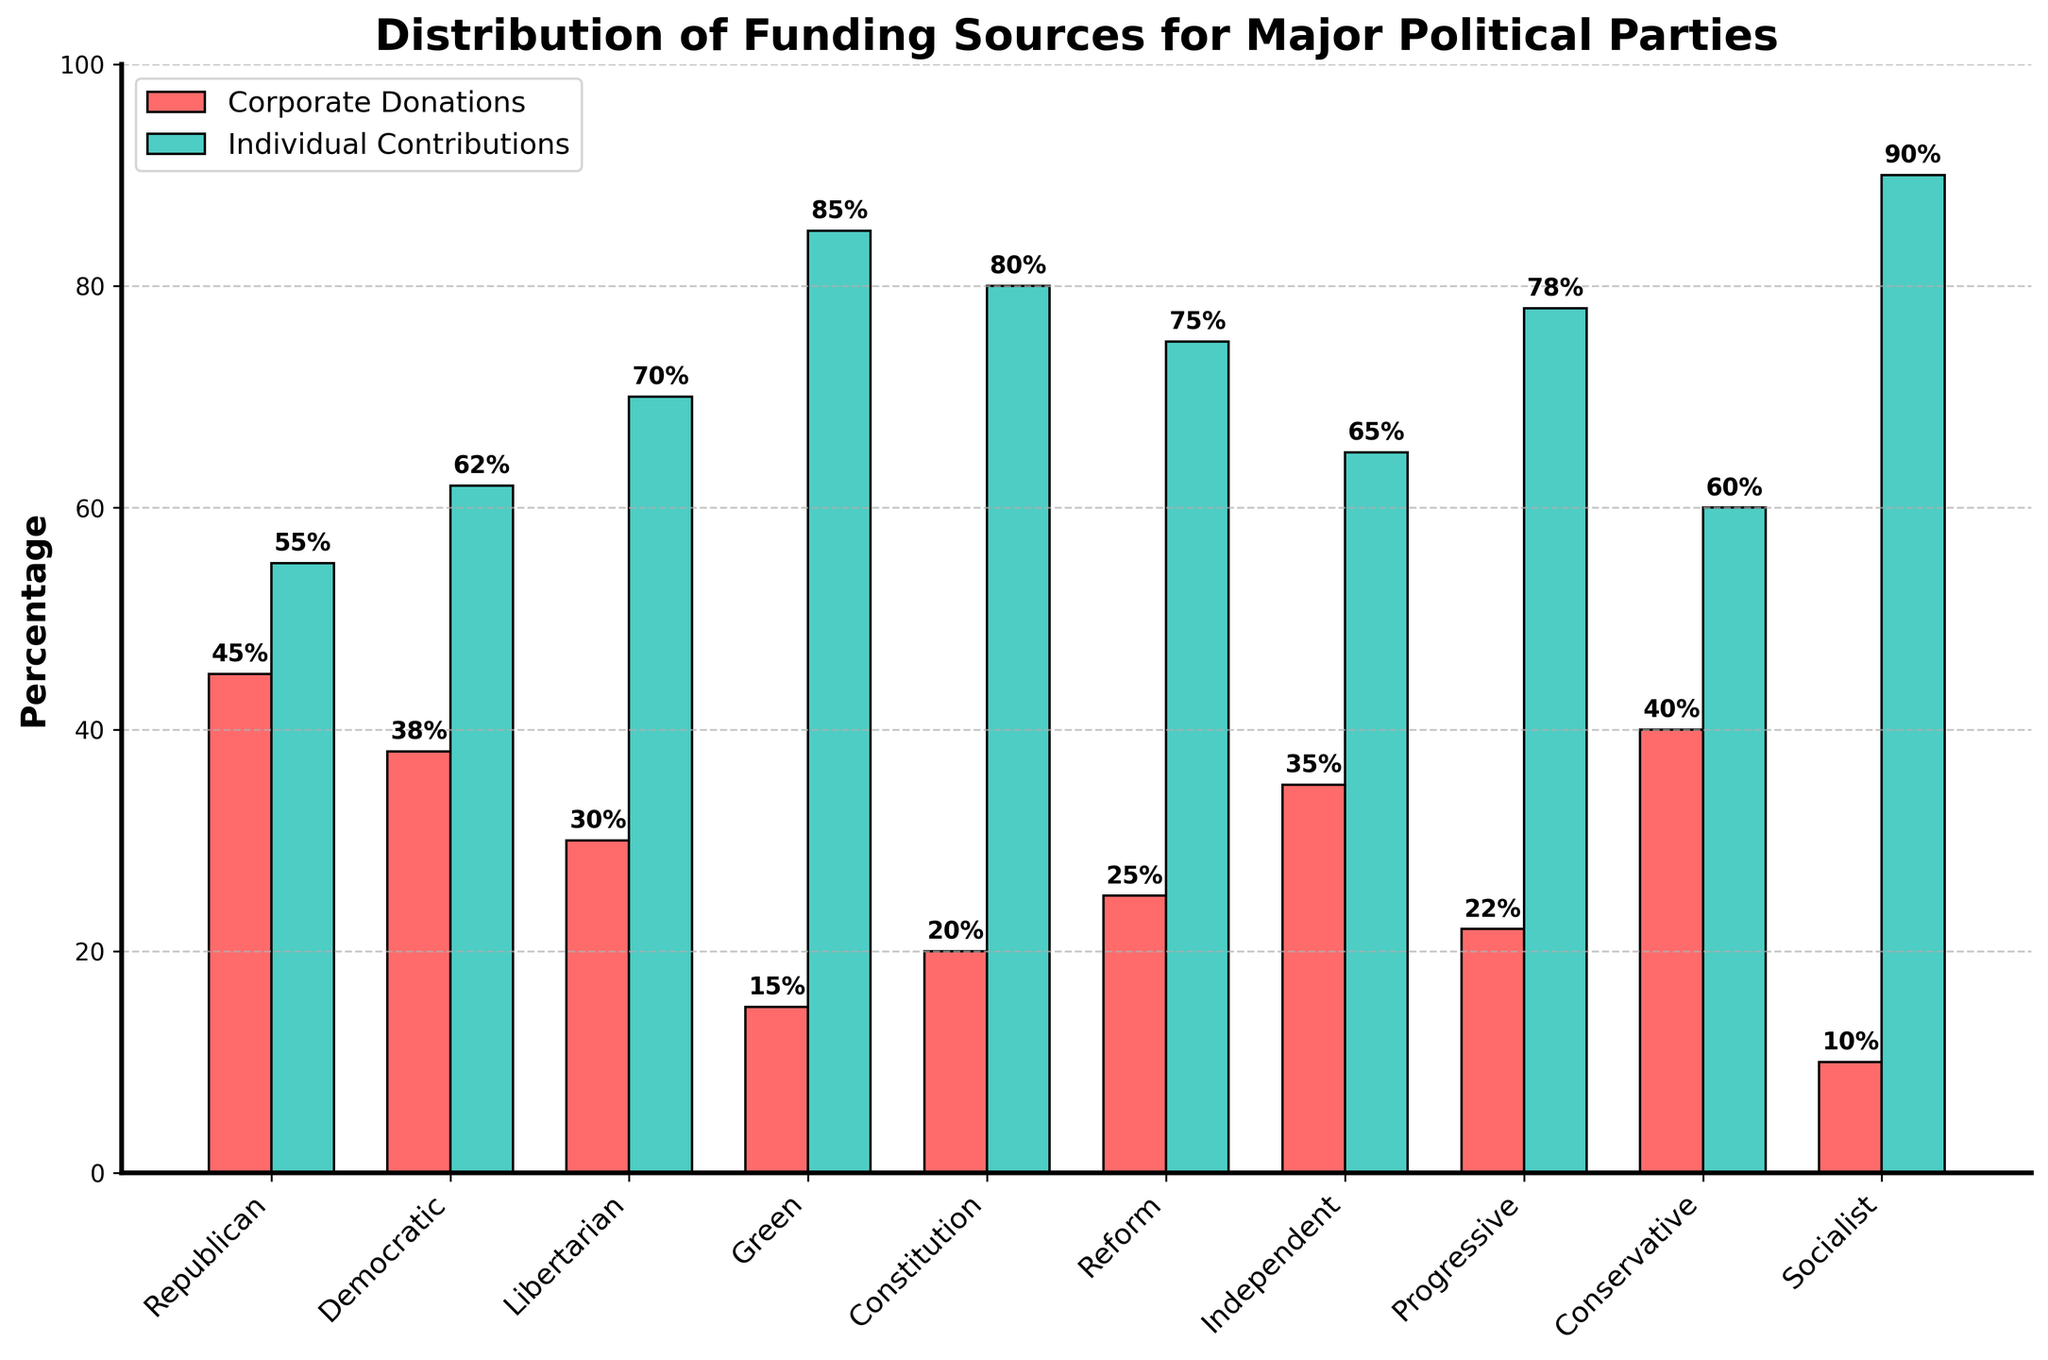What percentage of donations to the Republican party comes from corporate donations? The bar chart shows the percentage of corporate and individual donations for each party. For the Republican party, locate the bar representing corporate donations, which is labeled as red.
Answer: 45% Which political party receives the highest percent of individual contributions? Identify the green bar with the highest height across all parties. The highest bar for individual contributions corresponds to the Socialist party.
Answer: Socialist Among the Libertarian, Green, and Reform parties, which has the lowest percentage of corporate donations? Compare the red bars for the Libertarian, Green, and Reform parties. The Green party has the lowest corporate donations percentage among these three.
Answer: Green What's the total percentage for individual contributions received by the Progressive and Independent parties combined? Locate and add the individual contributions percentages for the Progressive (78%) and the Independent (65%) parties. The sum is 78% + 65% = 143%.
Answer: 143% Compare the corporate donations received by the Democratic and Constitution parties. Which one receives more and by how much? Identify and subtract the corporate donations percentage for the Constitution party (20%) from that of the Democratic party (38%). The Democratic party receives 38% - 20% = 18% more.
Answer: Democratic receives 18% more Which party has a larger percentage difference between corporate and individual contributions, Republican or Progressive? For the Republican party, the difference is 55% - 45% = 10%. For the Progressive party, the difference is 78% - 22% = 56%. Thus, the Progressive party has a larger difference.
Answer: Progressive Is there any party that receives exactly 25% corporate donations? Check the height of the red bars for each party to find 25%. The Reform party receives exactly 25% corporate donations.
Answer: Reform Among all parties, which receives the smallest percentage from corporate donations, and what is that percentage? Locate the shortest red bar across all parties, representing the smallest percentage of corporate donations, which corresponds to the Socialist party with 10%.
Answer: Socialist with 10% How do the corporate and individual contributions for the Conservative party compare? For the Conservative party, the corporate donations are 40% and the individual contributions are 60%. Individual contributions are higher by 60% - 40% = 20%.
Answer: Individual contributions are higher by 20% 